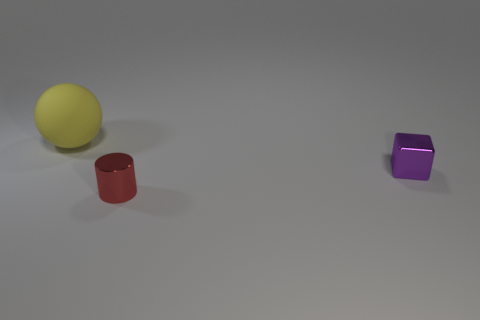How many shiny objects are to the right of the block?
Offer a terse response. 0. How many things are both behind the small red cylinder and in front of the big matte object?
Keep it short and to the point. 1. The thing that is made of the same material as the tiny red cylinder is what shape?
Give a very brief answer. Cube. Does the shiny object behind the cylinder have the same size as the metal thing that is left of the small purple metal thing?
Your response must be concise. Yes. There is a small object that is to the left of the purple shiny block; what is its color?
Make the answer very short. Red. What is the material of the tiny thing in front of the tiny object behind the small red object?
Your answer should be very brief. Metal. The red metallic thing is what shape?
Provide a succinct answer. Cylinder. How many yellow balls have the same size as the purple block?
Offer a very short reply. 0. There is a large object behind the small purple metal object; are there any red things behind it?
Your response must be concise. No. What number of red objects are small cubes or cylinders?
Provide a short and direct response. 1. 